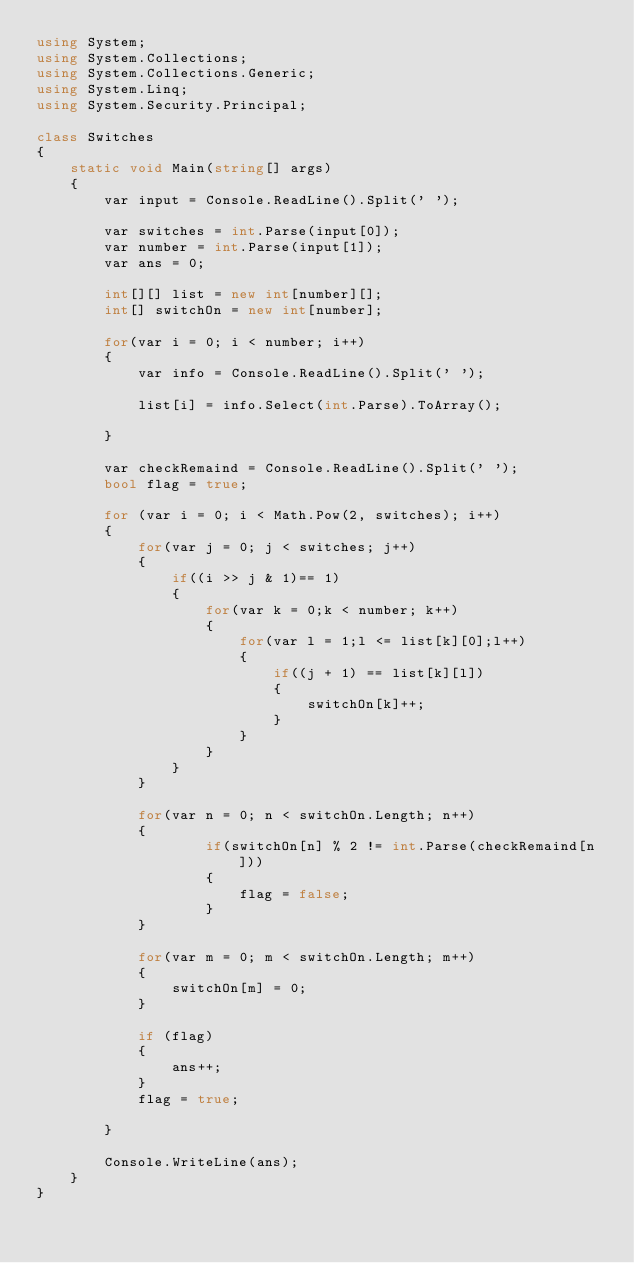<code> <loc_0><loc_0><loc_500><loc_500><_C#_>using System;
using System.Collections;
using System.Collections.Generic;
using System.Linq;
using System.Security.Principal;

class Switches
{
    static void Main(string[] args)
    {
        var input = Console.ReadLine().Split(' ');

        var switches = int.Parse(input[0]);
        var number = int.Parse(input[1]);
        var ans = 0;

        int[][] list = new int[number][];
        int[] switchOn = new int[number];

        for(var i = 0; i < number; i++)
        {
            var info = Console.ReadLine().Split(' ');
            
            list[i] = info.Select(int.Parse).ToArray();

        }

        var checkRemaind = Console.ReadLine().Split(' ');
        bool flag = true;

        for (var i = 0; i < Math.Pow(2, switches); i++)
        {
            for(var j = 0; j < switches; j++)
            {
                if((i >> j & 1)== 1)
                {
                    for(var k = 0;k < number; k++)
                    {
                        for(var l = 1;l <= list[k][0];l++)
                        {
                            if((j + 1) == list[k][l])
                            {
                                switchOn[k]++;
                            }
                        }
                    }
                }
            }

            for(var n = 0; n < switchOn.Length; n++)
            {
                    if(switchOn[n] % 2 != int.Parse(checkRemaind[n]))
                    {
                        flag = false;
                    }
            }

            for(var m = 0; m < switchOn.Length; m++)
            {
                switchOn[m] = 0;
            }

            if (flag)
            {
                ans++;
            }
            flag = true;

        }

        Console.WriteLine(ans);
    }
}</code> 